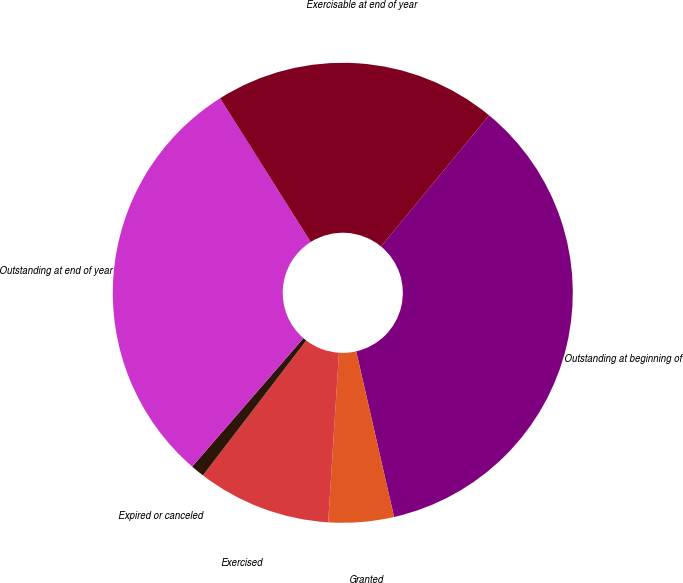Convert chart. <chart><loc_0><loc_0><loc_500><loc_500><pie_chart><fcel>Outstanding at beginning of<fcel>Granted<fcel>Exercised<fcel>Expired or canceled<fcel>Outstanding at end of year<fcel>Exercisable at end of year<nl><fcel>35.44%<fcel>4.59%<fcel>9.39%<fcel>0.96%<fcel>29.68%<fcel>19.93%<nl></chart> 